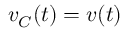Convert formula to latex. <formula><loc_0><loc_0><loc_500><loc_500>v _ { C } ( t ) = v ( t )</formula> 